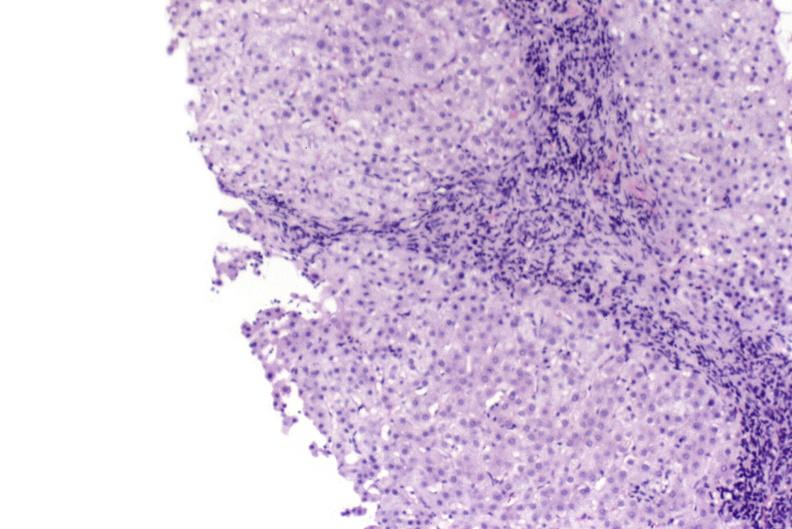what is present?
Answer the question using a single word or phrase. Liver 